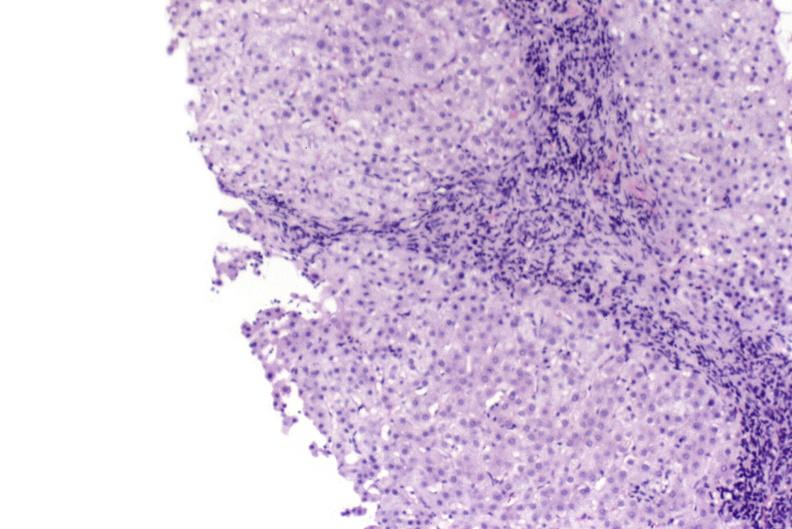what is present?
Answer the question using a single word or phrase. Liver 